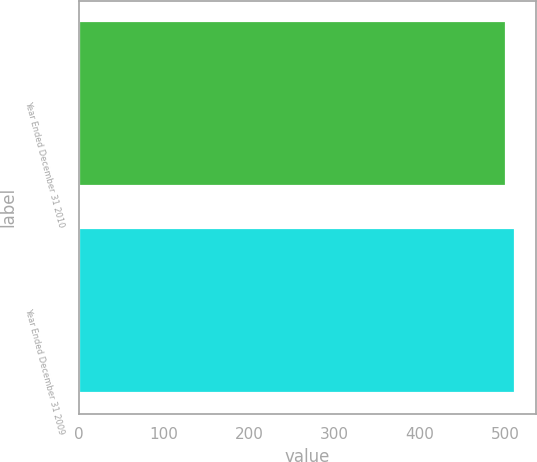Convert chart to OTSL. <chart><loc_0><loc_0><loc_500><loc_500><bar_chart><fcel>Year Ended December 31 2010<fcel>Year Ended December 31 2009<nl><fcel>501<fcel>511<nl></chart> 